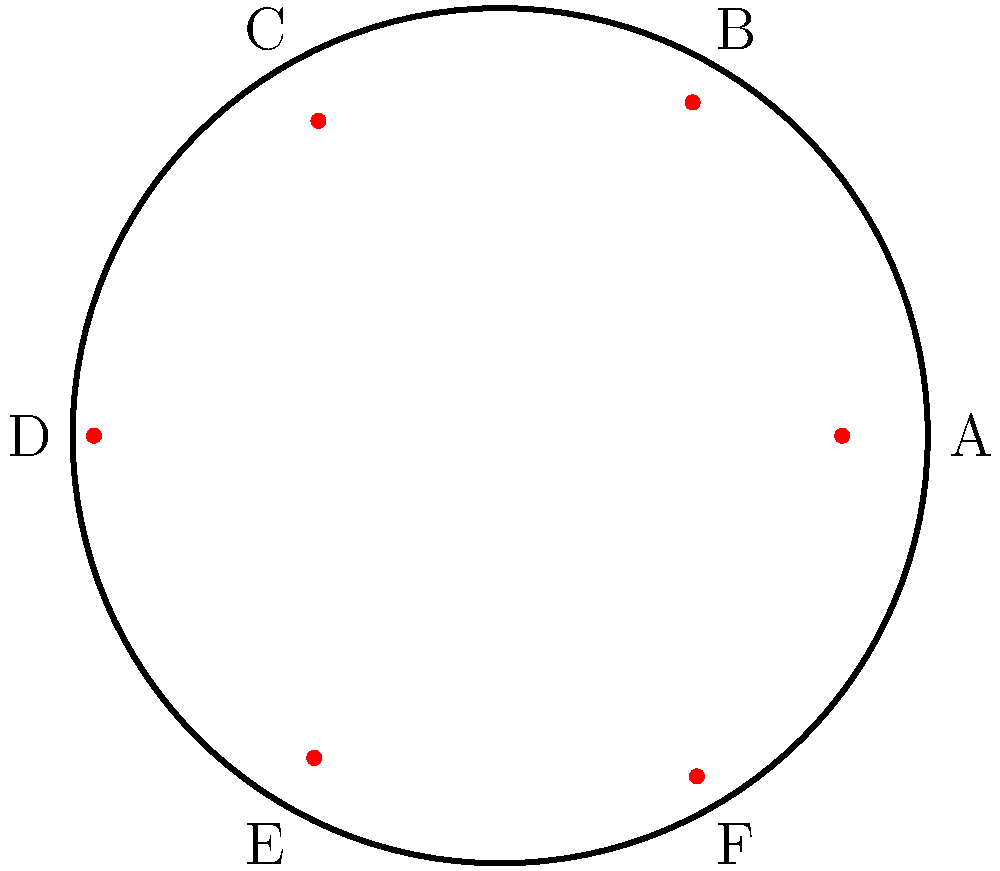In a circular chromosome map, genetic markers are plotted using polar coordinates $(r, \theta)$, where $r$ represents the radial distance from the center (0 ≤ r ≤ 1) and $\theta$ represents the angular position in radians. Given the following coordinates for six genetic markers:

A: $(0.8, 0)$
B: $(0.9, \frac{\pi}{3})$
C: $(0.85, \frac{2\pi}{3})$
D: $(0.95, \pi)$
E: $(0.87, \frac{4\pi}{3})$
F: $(0.92, \frac{5\pi}{3})$

Which two genetic markers are closest to each other in terms of their angular separation? To find the two genetic markers with the smallest angular separation, we need to compare the angular differences between adjacent markers:

1. Calculate the angular differences:
   A to B: $\frac{\pi}{3} - 0 = \frac{\pi}{3}$
   B to C: $\frac{2\pi}{3} - \frac{\pi}{3} = \frac{\pi}{3}$
   C to D: $\pi - \frac{2\pi}{3} = \frac{\pi}{3}$
   D to E: $\frac{4\pi}{3} - \pi = \frac{\pi}{3}$
   E to F: $\frac{5\pi}{3} - \frac{4\pi}{3} = \frac{\pi}{3}$
   F to A: $2\pi - \frac{5\pi}{3} = \frac{\pi}{3}$

2. Observe that all adjacent markers have the same angular separation of $\frac{\pi}{3}$ radians.

3. Since all adjacent pairs have the same angular separation, we need to consider the radial distances to determine which pair is closest.

4. Compare the radial distances:
   A: 0.8, B: 0.9, C: 0.85, D: 0.95, E: 0.87, F: 0.92

5. The pair with the most similar radial distances will be closest to each other.

6. The closest pair in terms of radial distance is E (0.87) and C (0.85).

Therefore, genetic markers C and E are closest to each other when considering both angular separation and radial distance.
Answer: C and E 